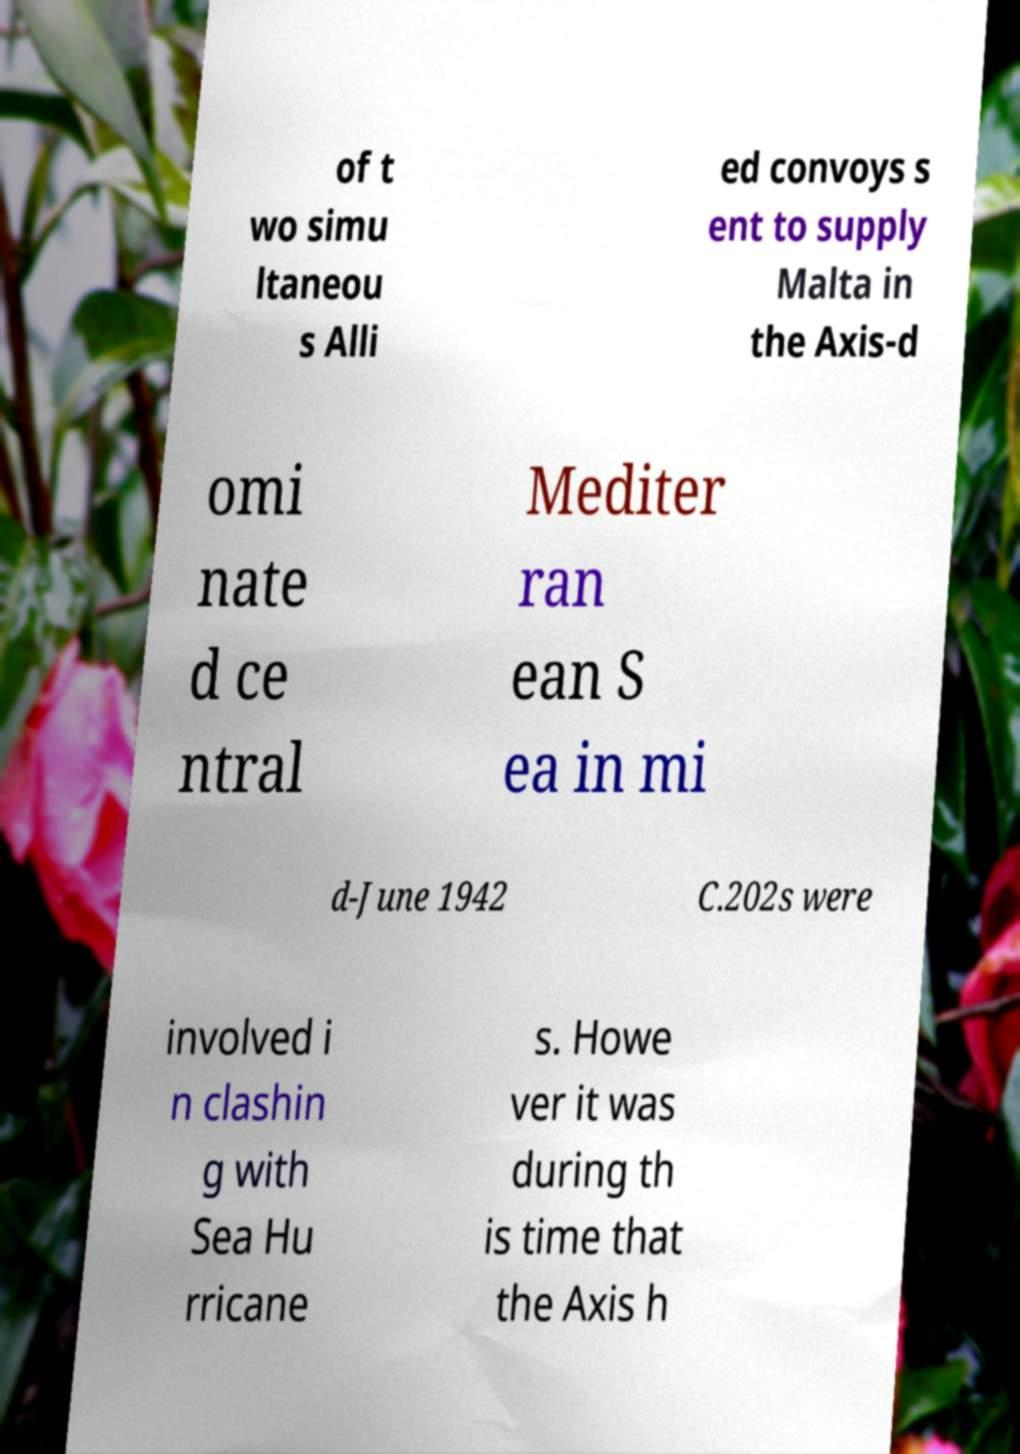Can you read and provide the text displayed in the image?This photo seems to have some interesting text. Can you extract and type it out for me? of t wo simu ltaneou s Alli ed convoys s ent to supply Malta in the Axis-d omi nate d ce ntral Mediter ran ean S ea in mi d-June 1942 C.202s were involved i n clashin g with Sea Hu rricane s. Howe ver it was during th is time that the Axis h 